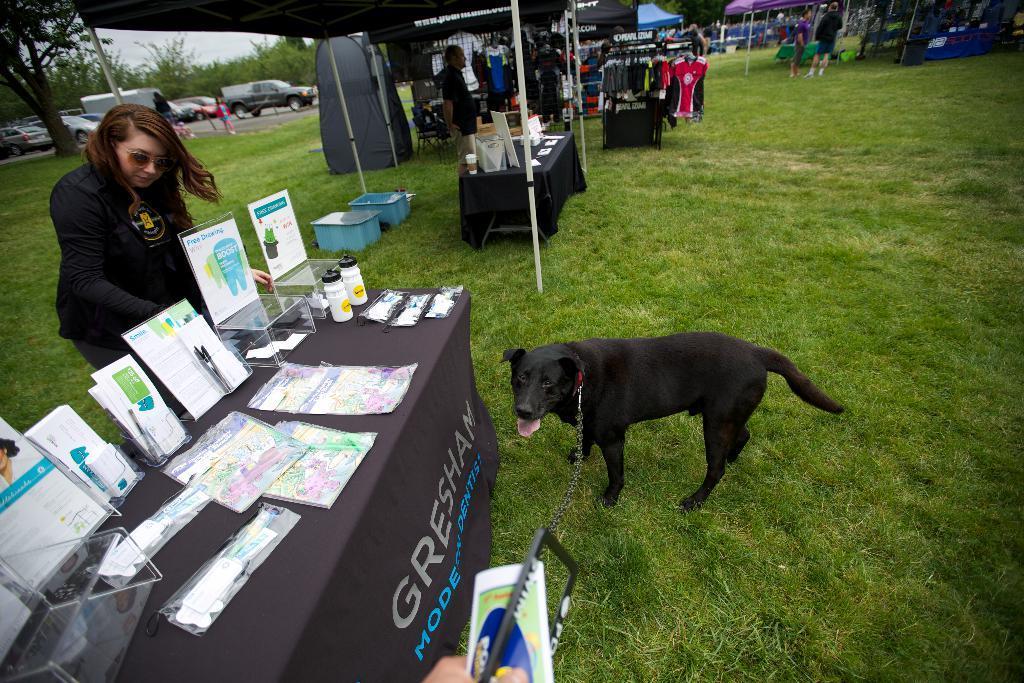Please provide a concise description of this image. In this image, we can persons wearing clothes. There are tables in the middle of the image contains bottles and some objects. There is a dog in front of the table. There are some cars and trees in the top left of the image. There are clothes and stalls at the top of the image. 